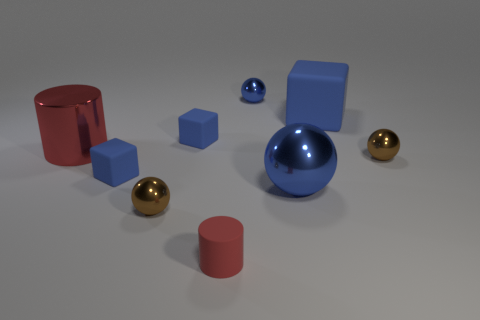Can you describe the lighting in the scene? The lighting appears to be soft and diffuse, coming from above. This is indicated by the gentle shadows cast by the objects, which are present but not overly sharp or dark. The reflections on the metallic and glossy surfaces also suggest a non-harsh, ambient light environment. 